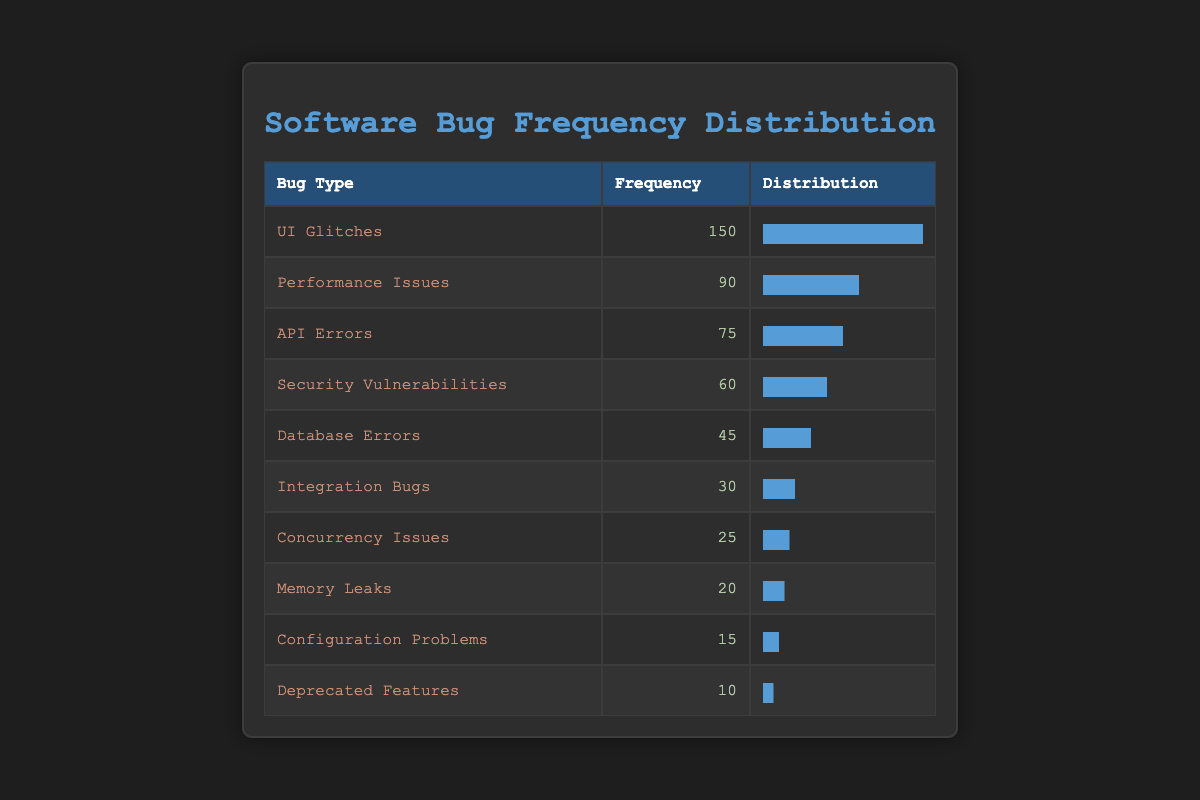What is the bug type with the highest frequency? The highest frequency in the table is found in the "UI Glitches" row, which shows a frequency of 150.
Answer: UI Glitches How many bugs reported are classified as "Security Vulnerabilities"? Looking at the table, the row for "Security Vulnerabilities" shows a frequency of 60 bugs reported.
Answer: 60 What is the total frequency of all reported bugs? Summing up the frequencies: 150 + 90 + 75 + 60 + 45 + 30 + 25 + 20 + 15 + 10 gives a total of 600 reported bugs.
Answer: 600 What percentage of the total bugs reported were "Memory Leaks"? The frequency of "Memory Leaks" is 20. The total frequency of all reported bugs is 600. To find the percentage, we calculate (20/600) * 100 = 3.33%.
Answer: 3.33% Are there more "UI Glitches" or "Performance Issues" reported? The frequency for "UI Glitches" is 150, while "Performance Issues" has a frequency of 90. Therefore, there are more "UI Glitches".
Answer: Yes What type of bugs has a frequency less than 50? The types of bugs with frequency less than 50 are "Database Errors" (45), "Integration Bugs" (30), "Concurrency Issues" (25), "Memory Leaks" (20), "Configuration Problems" (15), and "Deprecated Features" (10).
Answer: Database Errors, Integration Bugs, Concurrency Issues, Memory Leaks, Configuration Problems, Deprecated Features What is the average frequency of bugs reported? To find the average, we add together all frequencies (600) and divide by the number of categories (10), which gives us an average of 60.
Answer: 60 